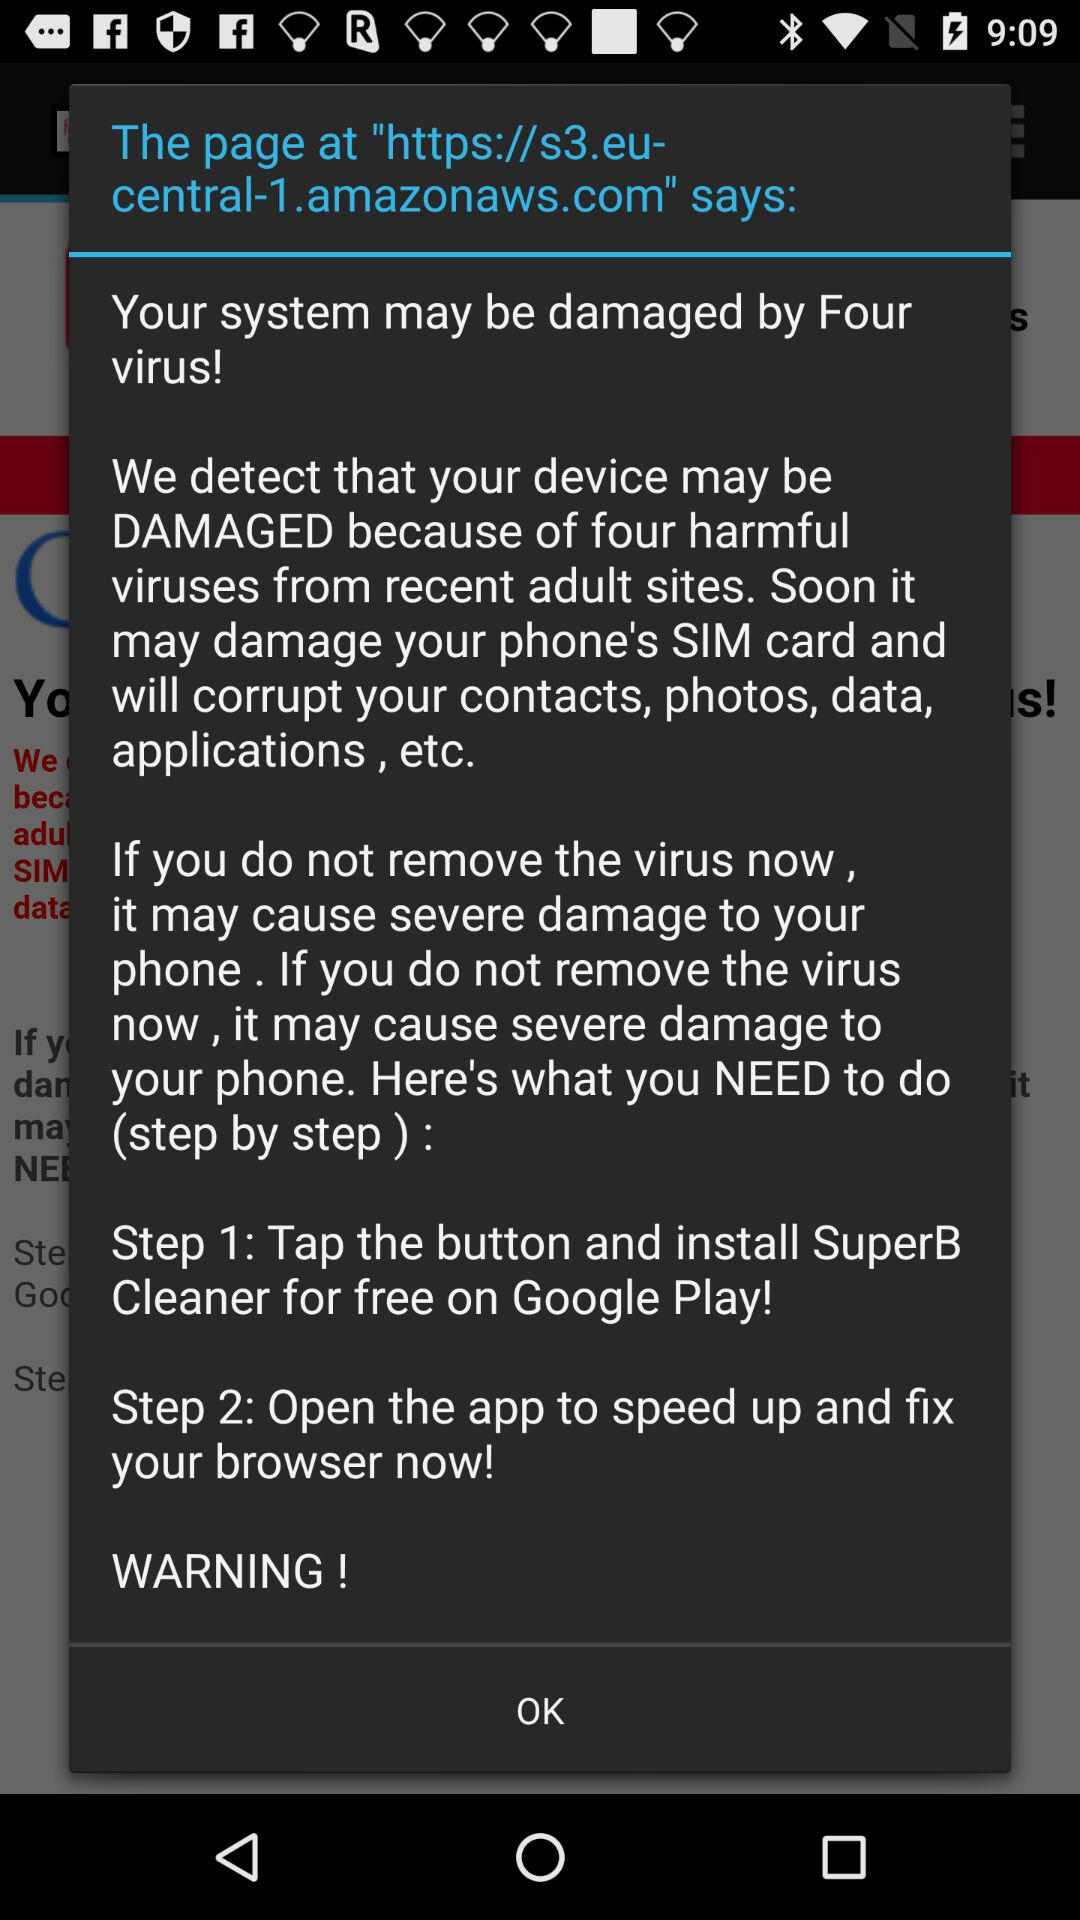How many steps does the user need to follow to fix the virus?
Answer the question using a single word or phrase. 2 